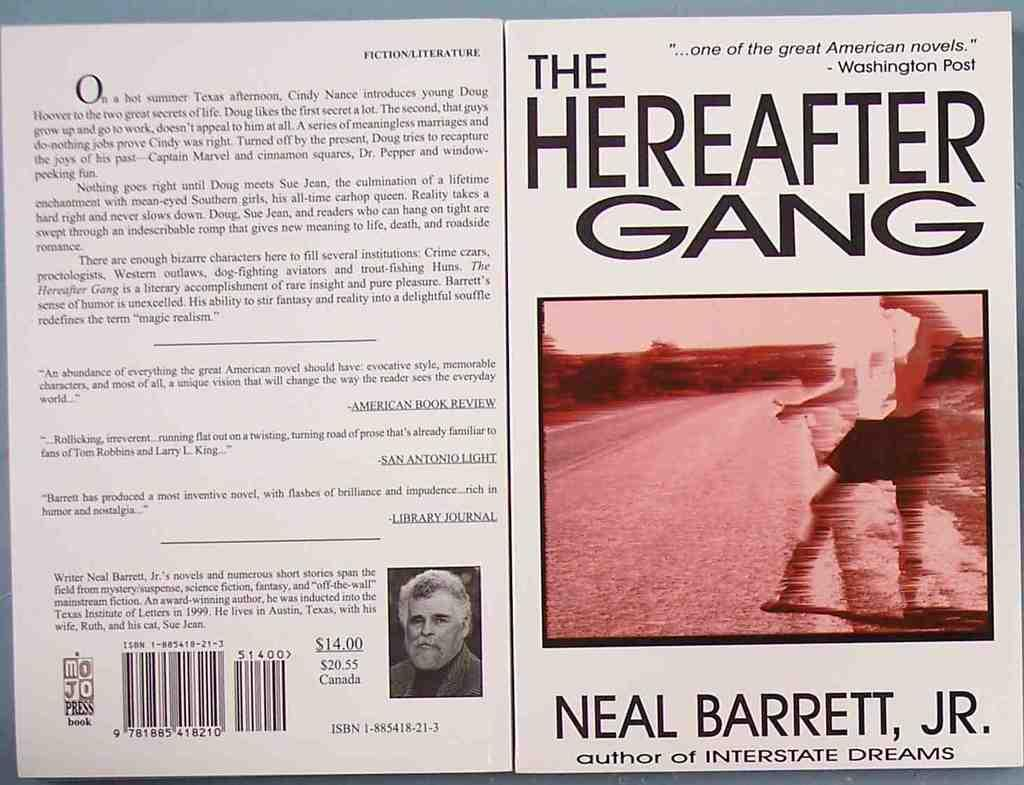Provide a one-sentence caption for the provided image. The front and back cover of a book written by Neal Barrett, Jr. 